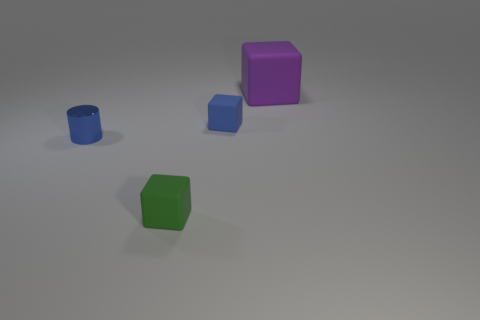Is the green object made of the same material as the big purple object?
Provide a short and direct response. Yes. There is a blue object that is the same size as the blue rubber block; what material is it?
Offer a terse response. Metal. How many objects are blue matte cubes left of the large matte thing or cubes?
Provide a short and direct response. 3. Are there the same number of tiny shiny cylinders that are in front of the green block and tiny green matte cubes?
Give a very brief answer. No. Is the big matte block the same color as the small metallic object?
Make the answer very short. No. What color is the rubber thing that is on the left side of the purple object and behind the blue cylinder?
Keep it short and to the point. Blue. How many cubes are purple objects or green objects?
Your response must be concise. 2. Are there fewer rubber objects on the left side of the small green block than large shiny balls?
Offer a terse response. No. What is the shape of the large object that is the same material as the green block?
Keep it short and to the point. Cube. How many cylinders are the same color as the small metallic thing?
Give a very brief answer. 0. 